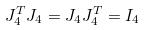Convert formula to latex. <formula><loc_0><loc_0><loc_500><loc_500>J _ { 4 } ^ { T } J _ { 4 } = J _ { 4 } J _ { 4 } ^ { T } = I _ { 4 }</formula> 